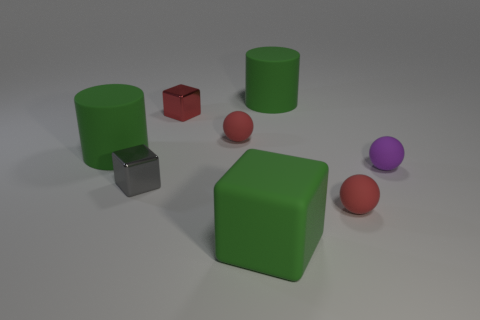How many objects are right of the large green matte block and in front of the small gray metallic block?
Your answer should be very brief. 1. What number of other objects are the same size as the purple rubber sphere?
Your response must be concise. 4. Does the small rubber thing that is on the left side of the green block have the same shape as the tiny matte thing in front of the tiny purple sphere?
Make the answer very short. Yes. How many objects are either large red things or cylinders that are right of the tiny red cube?
Make the answer very short. 1. There is a small object that is both behind the small purple thing and to the right of the red shiny object; what is its material?
Keep it short and to the point. Rubber. What is the color of the other object that is the same material as the tiny gray object?
Keep it short and to the point. Red. What number of things are either small purple spheres or small metal objects?
Provide a short and direct response. 3. There is a green block; is it the same size as the metal object in front of the small purple sphere?
Ensure brevity in your answer.  No. There is a matte object that is to the left of the small metallic cube in front of the large matte thing left of the big block; what is its color?
Provide a succinct answer. Green. What color is the big cube?
Your answer should be very brief. Green. 